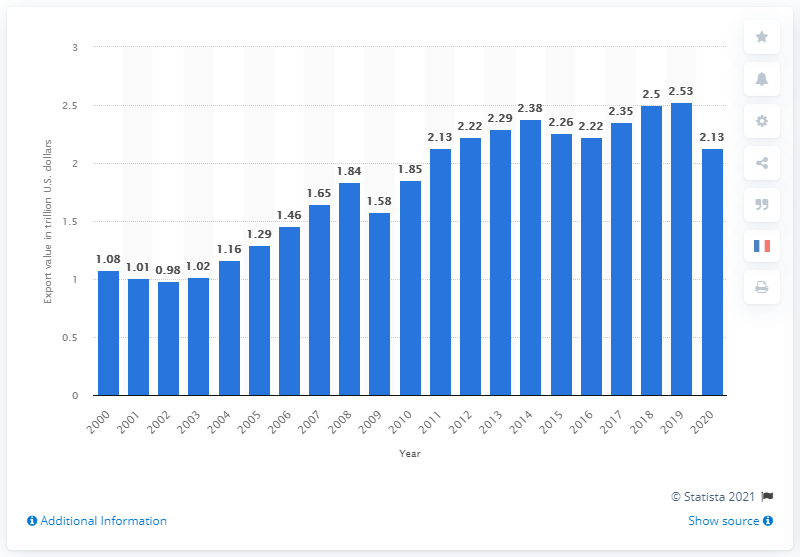Give some essential details in this illustration. In 2020, the total value of international U.S. exports of goods and services was 2.13 trillion dollars. 